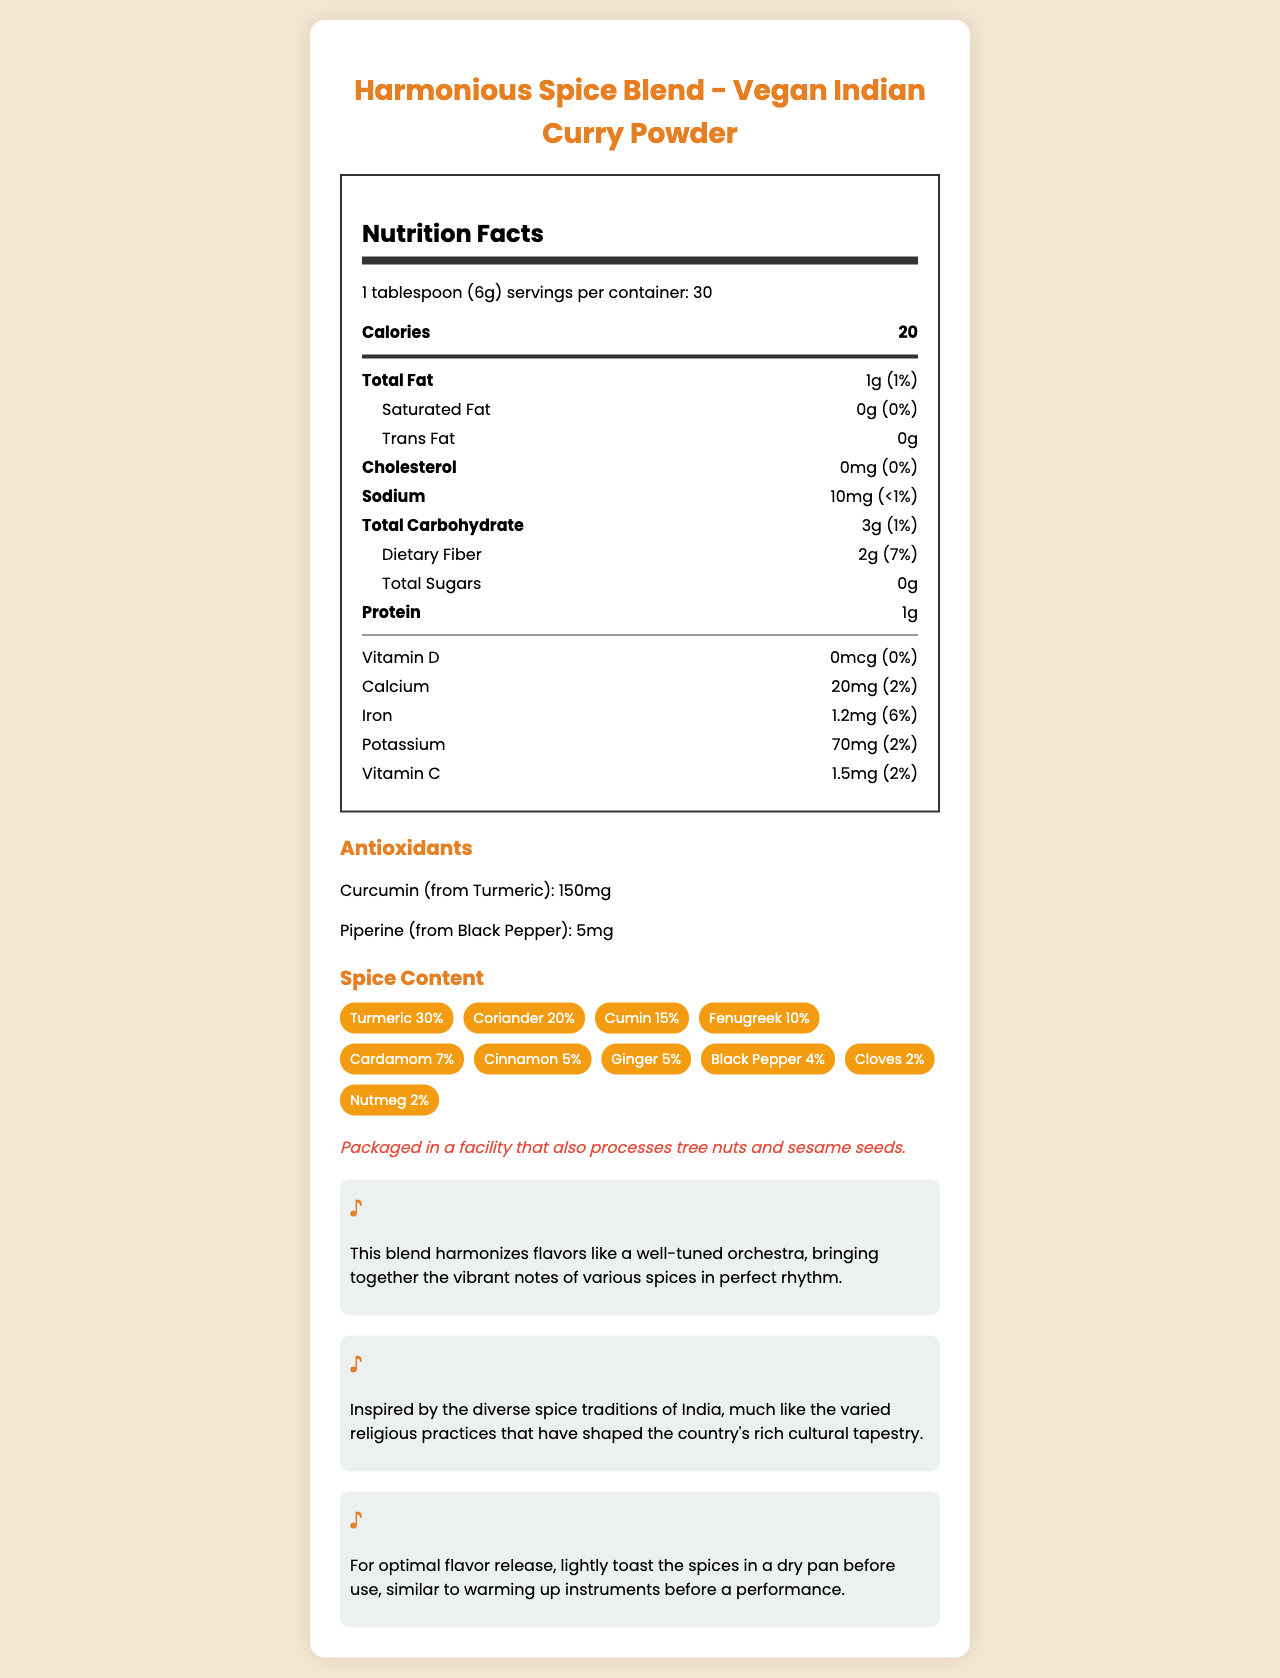what is the serving size for the Harmonious Spice Blend? The serving size is explicitly mentioned at the top section of the Nutrition Facts label.
Answer: 1 tablespoon (6g) how many servings are there per container? The document specifies that there are 30 servings per container, listed next to the serving size.
Answer: 30 how many calories are in one serving of the curry powder blend? The calories per serving are clearly listed as 20 right under the servings per container.
Answer: 20 how much dietary fiber is in one serving? The dietary fiber content is indicated in the nutritional facts under total carbohydrate as 2g.
Answer: 2g what are the two antioxidants listed and their amounts? The antioxidants are specifically listed in their own section, showing the amounts of curcumin and piperine.
Answer: Curcumin (from Turmeric): 150mg, Piperine (from Black Pepper): 5mg which vitamin provides the highest daily value percentage, and what is it? Vitamin D provides the highest percentage, being explicitly stated as 0% daily value in the nutrition label.
Answer: Vitamin D: 0% daily value what is the main ingredient by percentage in the spice content? A. Coriander B. Turmeric C. Cumin The highest percentage spice is Turmeric, making up 30% of the blend, which is the highest among all listed spices.
Answer: B. Turmeric for how many grams of total carbohydrate does the curry powder contain? A. 1g B. 3g C. 5g D. 10g Total carbohydrate content is listed as 3g per serving, as stated in the nutritional facts.
Answer: B. 3g is the Harmonious Spice Blend packaged in a facility that processes tree nuts? The allergen information clearly states that the product is packaged in a facility that also processes tree nuts.
Answer: Yes summarize the primary features and nutrition of Harmonious Spice Blend. This summary captures the essential aspects of the spice mix, including its nutritional content, flavor profile, usage suggestions, and cultural background.
Answer: The Harmonious Spice Blend - Vegan Indian Curry Powder is a spice mix containing various spices and antioxidants like Curcumin and Piperine. It has low calories (20 per serving), low fats, no cholesterol, and is a good source of dietary fiber. The blend contains notable spices such as Turmeric, Coriander, and Cumin, and should be used toasted for optimal flavor. The allergen information warns that it is packaged in a facility processing tree nuts and sesame seeds. It also carries cultural notes related to Indian spice traditions. which preparation tip is suggested for the optimal flavor release of the spices? The preparation tip section suggests toasting the spices in a dry pan to release their optimal flavor.
Answer: Lightly toast the spices in a dry pan before use how much iron does one serving of the blend provide, and what percentage of daily value does it cover? The nutrition facts label indicates that a serving provides 1.2mg of iron, which is 6% of the daily value.
Answer: 1.2mg, 6% what are the major allergens indicated for this spice blend? The allergen information clearly states that it is packaged in a facility processing tree nuts and sesame seeds.
Answer: Tree nuts and sesame seeds what is the overall flavor profile of the Harmonious Spice Blend described as? The musical note section describes the flavor profile using a musical metaphor, emphasizing the harmony and vibrant mix of spices.
Answer: Bringing together the vibrant notes of various spices in perfect rhythm. what is the total dietary fiber in 3 servings of the spice blend? Each serving contains 2g of dietary fiber, so 3 servings would have 2g x 3 = 6g of dietary fiber.
Answer: 6g where are the spices from this blend inspired by, culturally? The cultural insight section mentions that the blend is inspired by the diverse spice traditions of India.
Answer: The diverse spice traditions of India how much potassium is provided per serving, and is it a high or low amount? The document states 70mg of potassium per serving, and based on nutrient standards, this is considered a low amount of potassium.
Answer: 70mg, low amount what is the percentage of cinnamon in the blend? The spice content section lists each spice and its percentage in the blend, with cinnamon given as 5%.
Answer: 5% how many grams of total sugars are in the blend? The nutritional facts explicitly state that the total sugars per serving are 0g.
Answer: 0g who is the Harmonious Spice Blend marketed towards primarily? The document does not provide specific marketing information targeting a particular audience.
Answer: Cannot be determined how many calories are in two servings of the blend? With each serving containing 20 calories, two servings would be 20 calories x 2 = 40 calories.
Answer: 40 